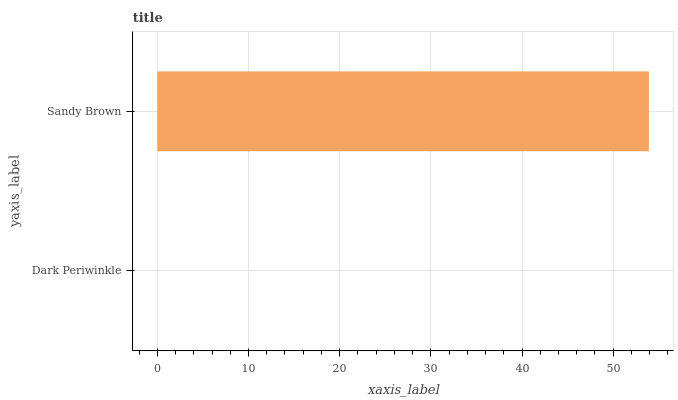Is Dark Periwinkle the minimum?
Answer yes or no. Yes. Is Sandy Brown the maximum?
Answer yes or no. Yes. Is Sandy Brown the minimum?
Answer yes or no. No. Is Sandy Brown greater than Dark Periwinkle?
Answer yes or no. Yes. Is Dark Periwinkle less than Sandy Brown?
Answer yes or no. Yes. Is Dark Periwinkle greater than Sandy Brown?
Answer yes or no. No. Is Sandy Brown less than Dark Periwinkle?
Answer yes or no. No. Is Sandy Brown the high median?
Answer yes or no. Yes. Is Dark Periwinkle the low median?
Answer yes or no. Yes. Is Dark Periwinkle the high median?
Answer yes or no. No. Is Sandy Brown the low median?
Answer yes or no. No. 